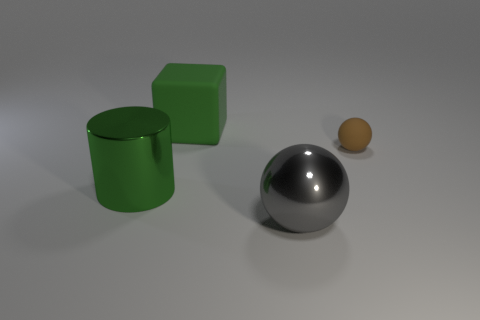Add 3 large blue spheres. How many objects exist? 7 Subtract all brown balls. How many balls are left? 1 Subtract all cyan blocks. How many gray balls are left? 1 Subtract all large gray things. Subtract all green metal things. How many objects are left? 2 Add 2 large green metal cylinders. How many large green metal cylinders are left? 3 Add 4 large matte cubes. How many large matte cubes exist? 5 Subtract 0 green spheres. How many objects are left? 4 Subtract all cylinders. How many objects are left? 3 Subtract 1 balls. How many balls are left? 1 Subtract all yellow blocks. Subtract all gray spheres. How many blocks are left? 1 